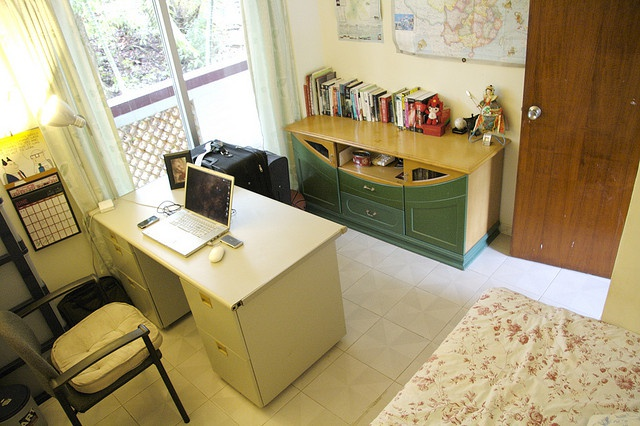Describe the objects in this image and their specific colors. I can see bed in khaki and tan tones, chair in khaki, black, olive, and tan tones, book in khaki, tan, black, and darkgray tones, laptop in khaki, white, and black tones, and suitcase in khaki, black, gray, darkgray, and white tones in this image. 